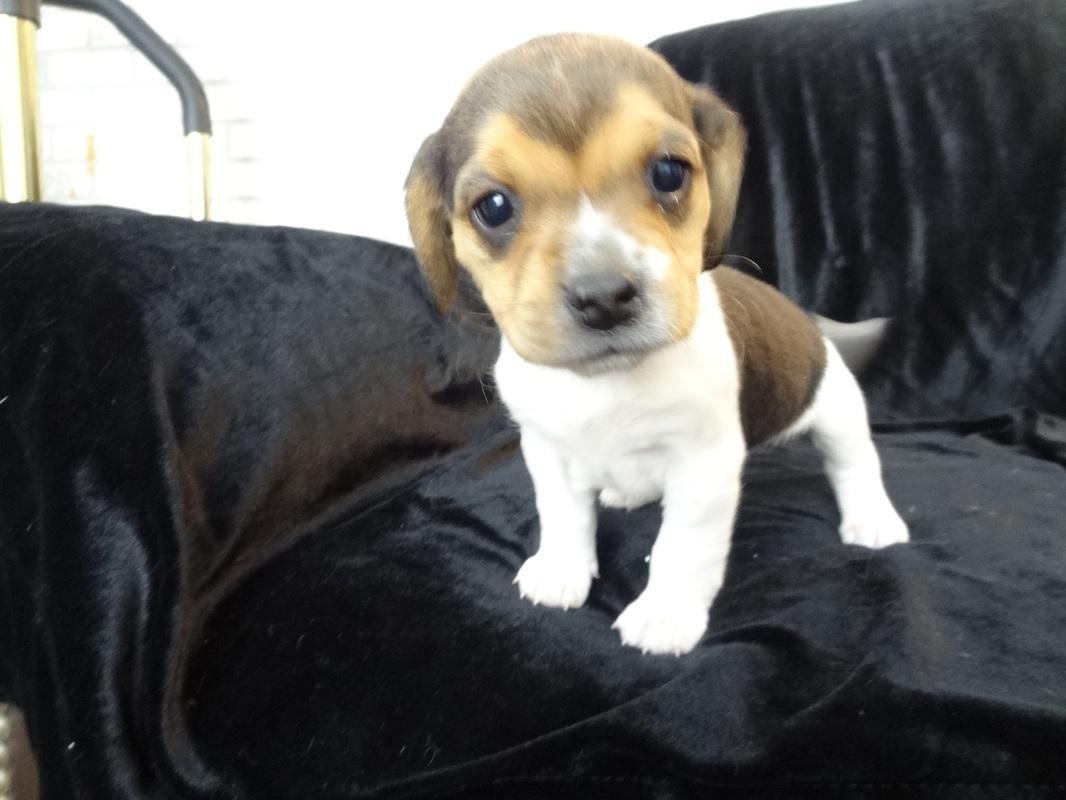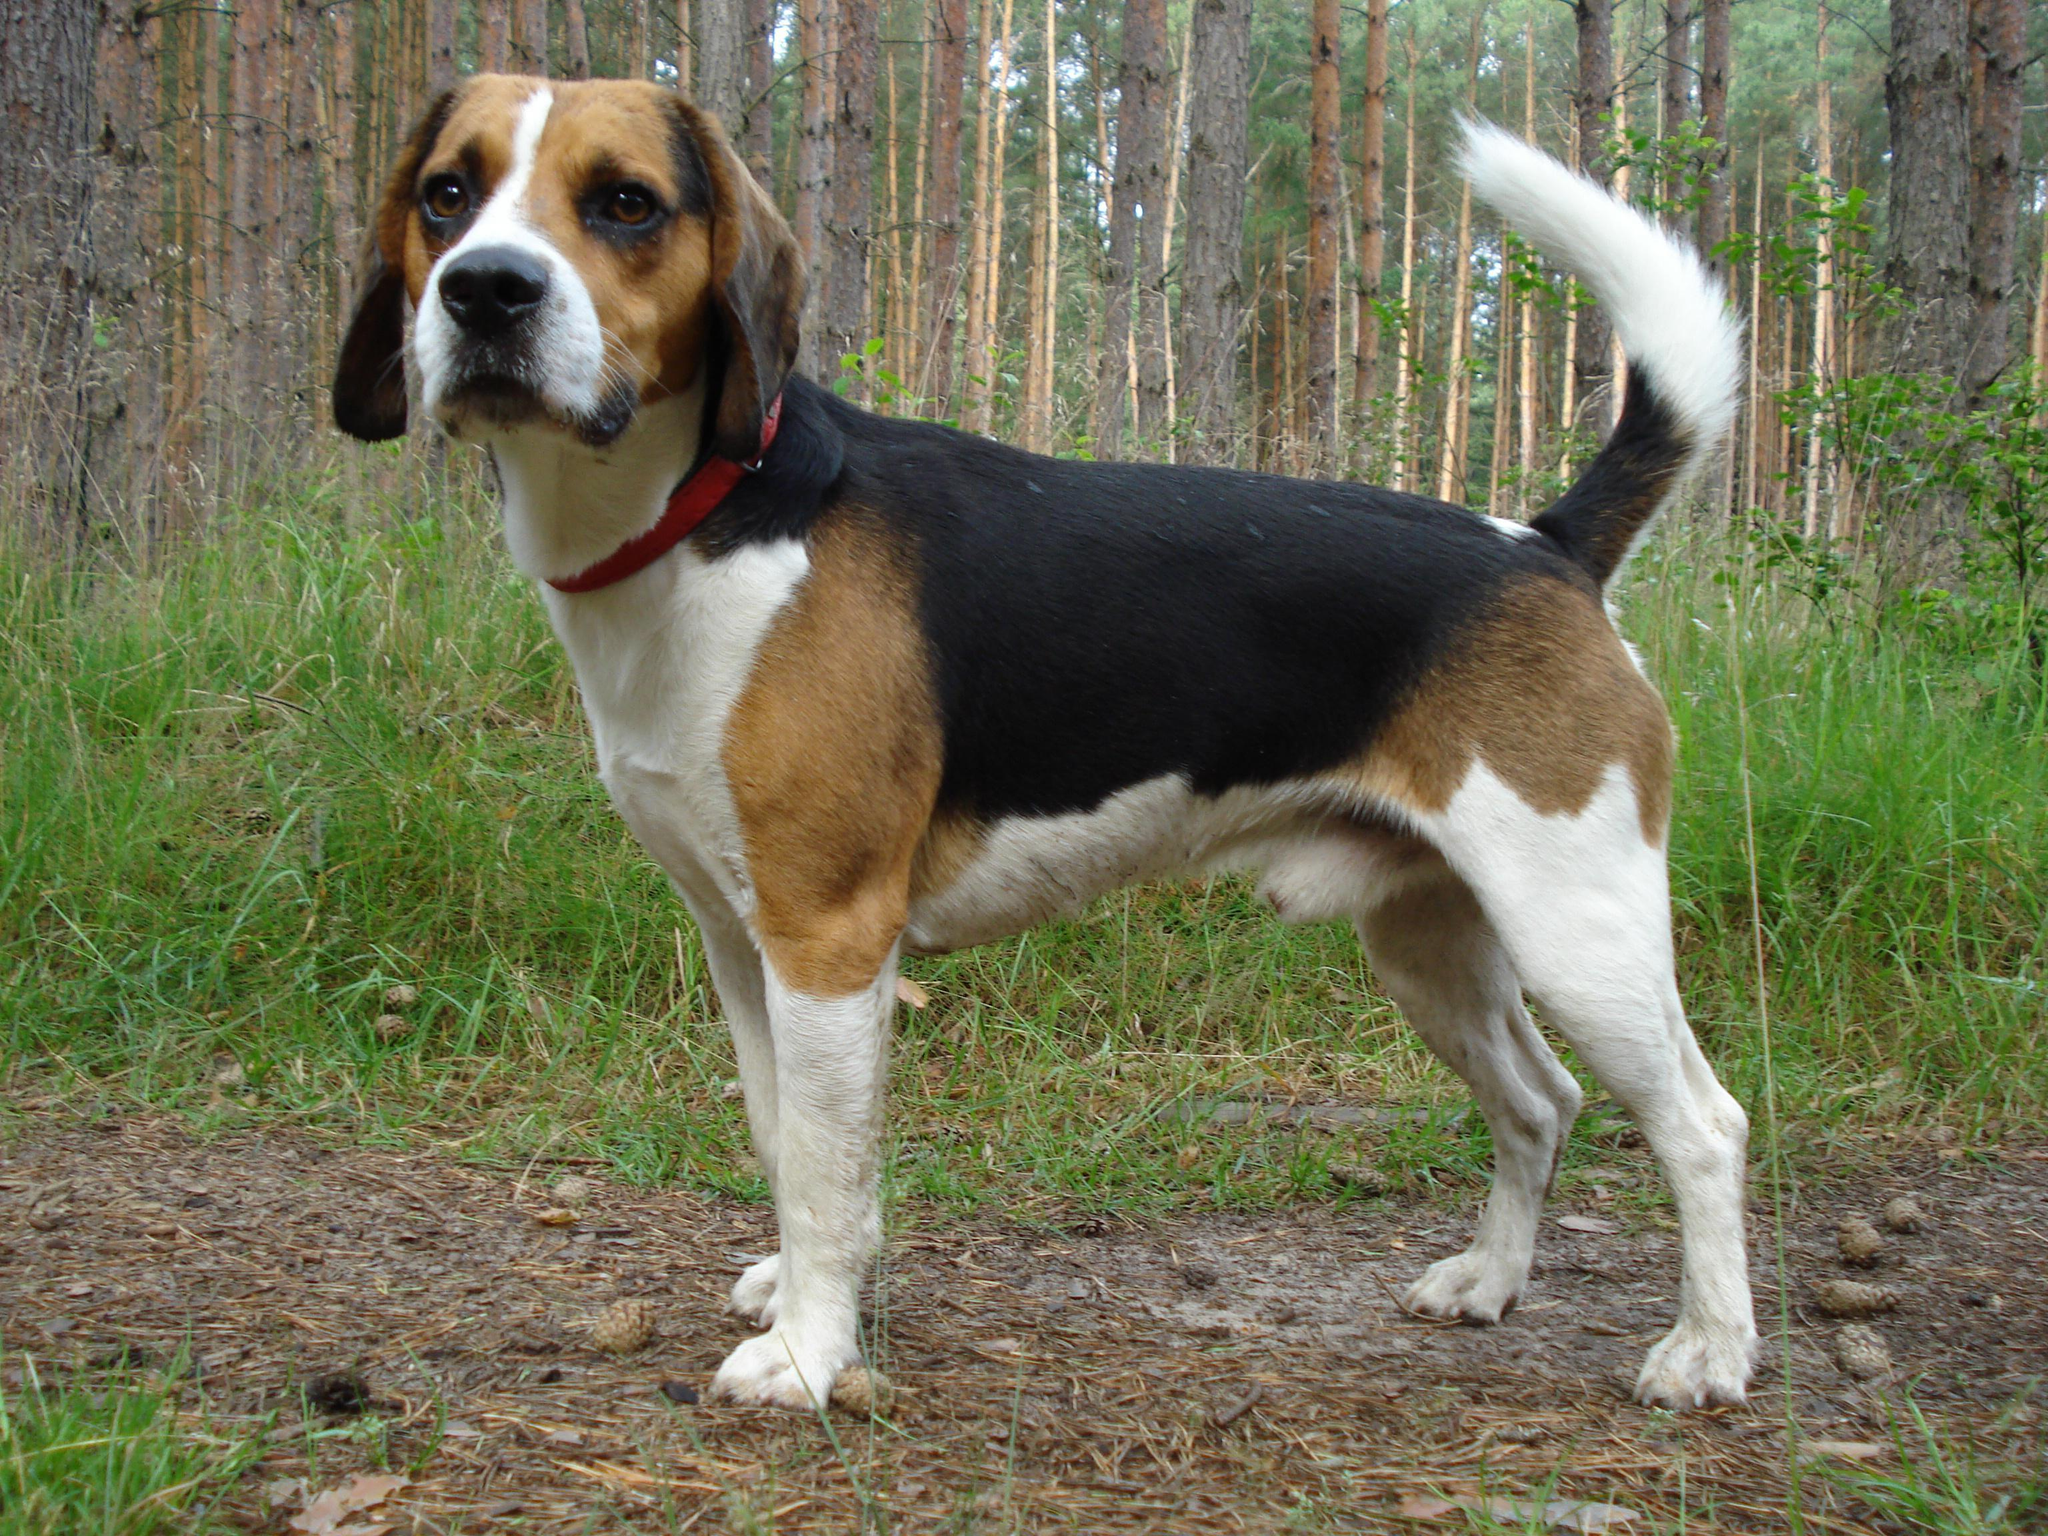The first image is the image on the left, the second image is the image on the right. Examine the images to the left and right. Is the description "At least one of the dogs is inside." accurate? Answer yes or no. Yes. The first image is the image on the left, the second image is the image on the right. Considering the images on both sides, is "At least one dog is one a leash in one of the images." valid? Answer yes or no. No. 